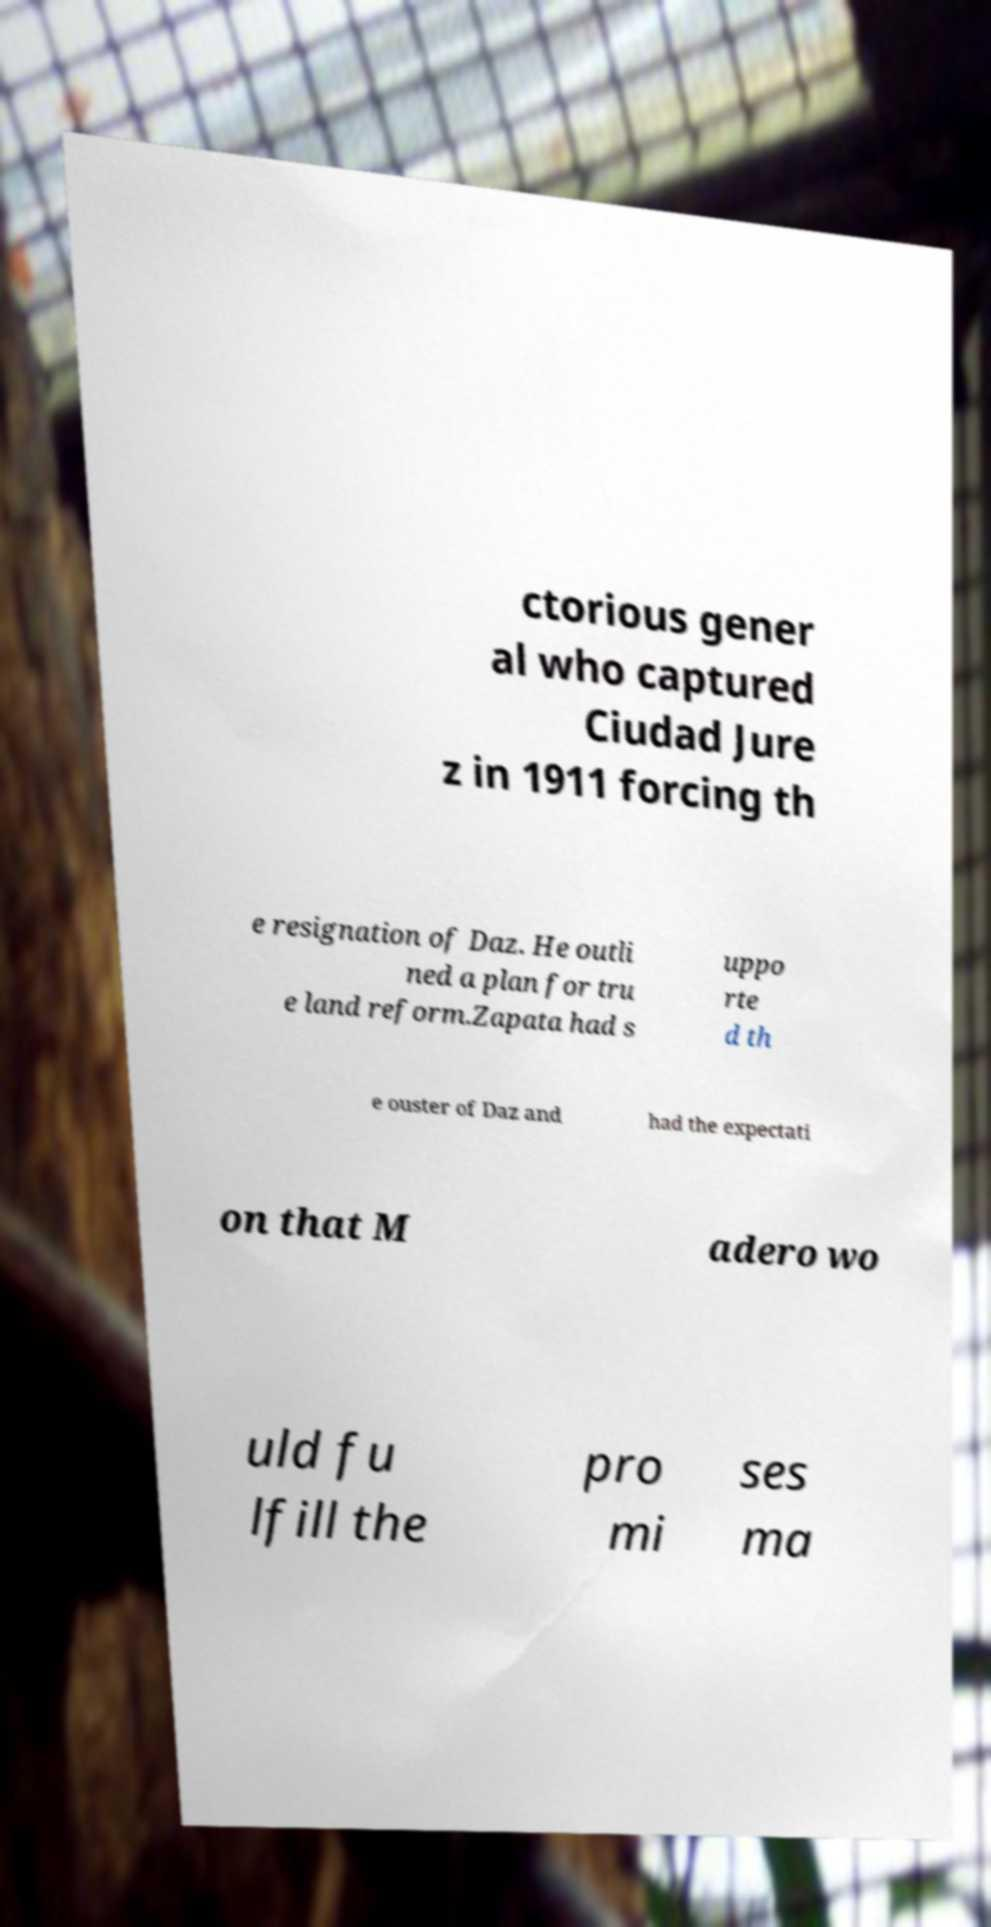There's text embedded in this image that I need extracted. Can you transcribe it verbatim? ctorious gener al who captured Ciudad Jure z in 1911 forcing th e resignation of Daz. He outli ned a plan for tru e land reform.Zapata had s uppo rte d th e ouster of Daz and had the expectati on that M adero wo uld fu lfill the pro mi ses ma 